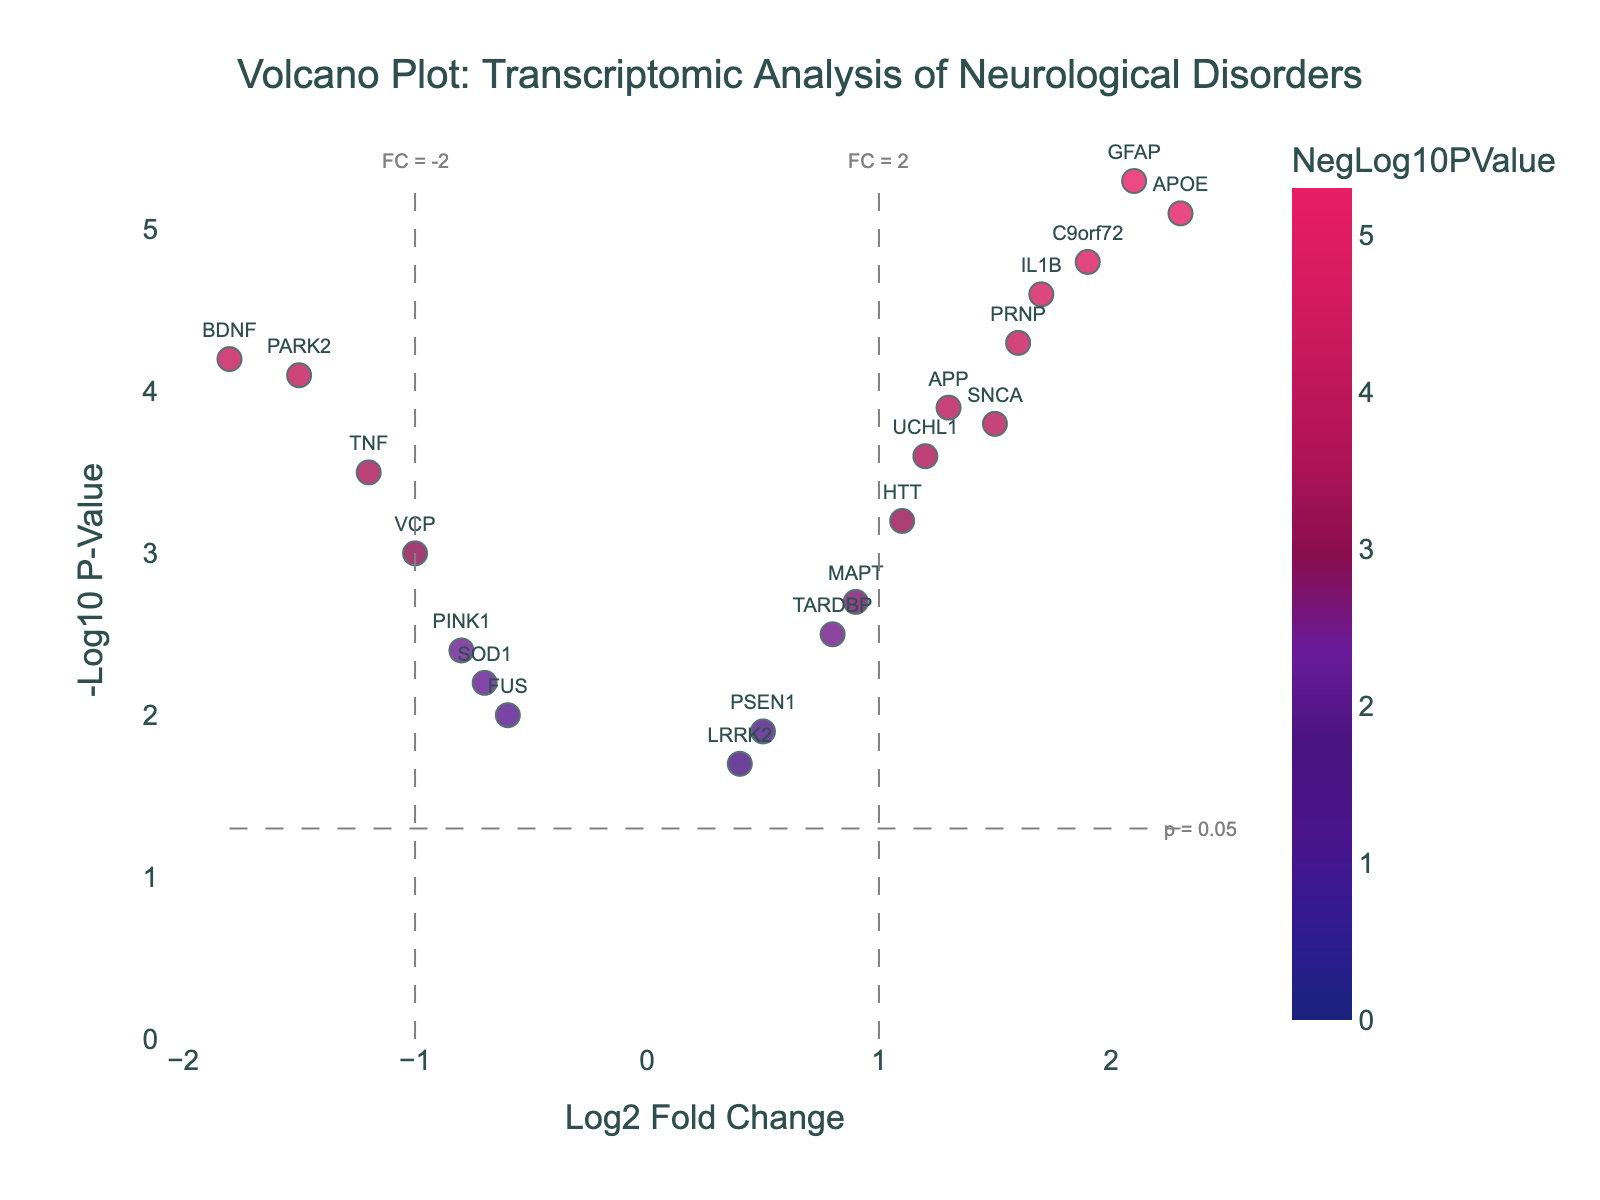What is the title of the volcano plot? The title appears at the top of the figure and provides a summary of what the data represents. In this case, the title explicitly describes the comparison made in the transcriptomic analysis.
Answer: Volcano Plot: Transcriptomic Analysis of Neurological Disorders How many genes have a Log2 Fold Change greater than 1? To find this, count all the genes in the figure whose data points are located to the right of Log2 Fold Change = 1 on the x-axis.
Answer: 6 Which gene has the highest -Log10 P-Value? Look for the data point that is highest on the y-axis, since -Log10 P-Value is plotted along the y-axis.
Answer: GFAP Are there more genes with positive or negative Log2 Fold Change? Count all the points to the right of the y-axis for positive Log2 Fold Change and to the left for negative Log2 Fold Change, then compare.
Answer: More genes have positive Log2 Fold Change What are the Log2 Fold Change and -Log10 P-Value for the gene APOE? Locate the data point labeled APOE and read its x and y coordinates, which correspond to Log2 Fold Change and -Log10 P-Value, respectively.
Answer: Log2 Fold Change: 2.3, -Log10 P-Value: 5.1 How many genes have a significant p-value assuming alpha = 0.05? A p-value is significant if -Log10(p-value) > 1.3 (since -log10(0.05) ≈ 1.3). Count the points above y = 1.3.
Answer: 16 Which gene has the smallest Fold Change in absolute value and what is its significance level? Identify the gene with the Log2 Fold Change closest to zero and then find its corresponding -Log10 P-Value on the y-axis.
Answer: LRRK2, -Log10 P-Value: 1.7 What genes are on the threshold lines of Log2 Fold Change = ±1? Locate the data points precisely on the vertical dashed lines at x = 1 and x = -1, representing the critical fold change thresholds.
Answer: IL1B, UCHL1, TNF, PARK2 Compare the -Log10 P-Values of IL1B and BDNF. Which is higher and by how much? Find the -Log10 P-Values from the y-axis for IL1B and BDNF and compute the difference.
Answer: IL1B is higher by 0.4 Which gene with a negative Log2 Fold Change is most statistically significant and what is its statistical significance? Identify the highest data point on the left side of the y-axis (negative Log2 Fold Change), indicating the most significant gene.
Answer: BDNF, -Log10 P-Value: 4.2 